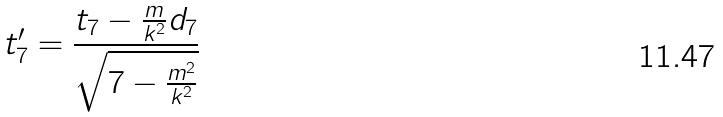<formula> <loc_0><loc_0><loc_500><loc_500>t _ { 7 } ^ { \prime } = \frac { t _ { 7 } - \frac { m } { k ^ { 2 } } d _ { 7 } } { \sqrt { 7 - \frac { m ^ { 2 } } { k ^ { 2 } } } }</formula> 